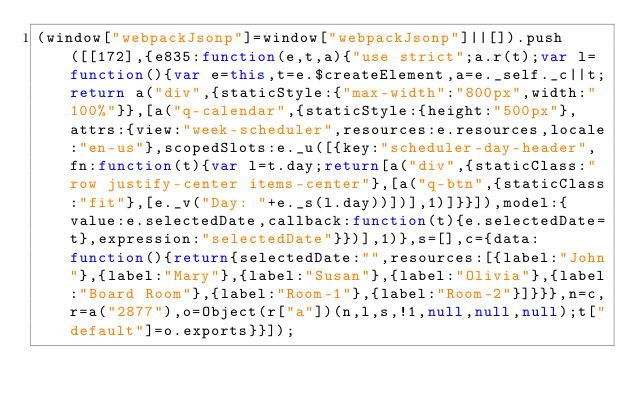<code> <loc_0><loc_0><loc_500><loc_500><_JavaScript_>(window["webpackJsonp"]=window["webpackJsonp"]||[]).push([[172],{e835:function(e,t,a){"use strict";a.r(t);var l=function(){var e=this,t=e.$createElement,a=e._self._c||t;return a("div",{staticStyle:{"max-width":"800px",width:"100%"}},[a("q-calendar",{staticStyle:{height:"500px"},attrs:{view:"week-scheduler",resources:e.resources,locale:"en-us"},scopedSlots:e._u([{key:"scheduler-day-header",fn:function(t){var l=t.day;return[a("div",{staticClass:"row justify-center items-center"},[a("q-btn",{staticClass:"fit"},[e._v("Day: "+e._s(l.day))])],1)]}}]),model:{value:e.selectedDate,callback:function(t){e.selectedDate=t},expression:"selectedDate"}})],1)},s=[],c={data:function(){return{selectedDate:"",resources:[{label:"John"},{label:"Mary"},{label:"Susan"},{label:"Olivia"},{label:"Board Room"},{label:"Room-1"},{label:"Room-2"}]}}},n=c,r=a("2877"),o=Object(r["a"])(n,l,s,!1,null,null,null);t["default"]=o.exports}}]);</code> 